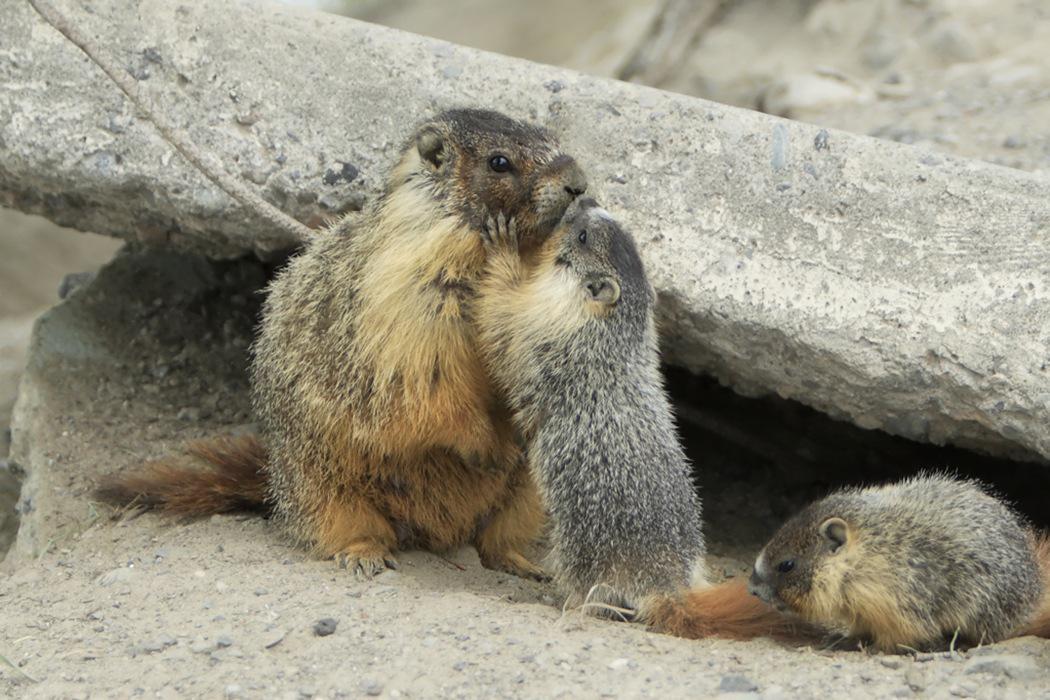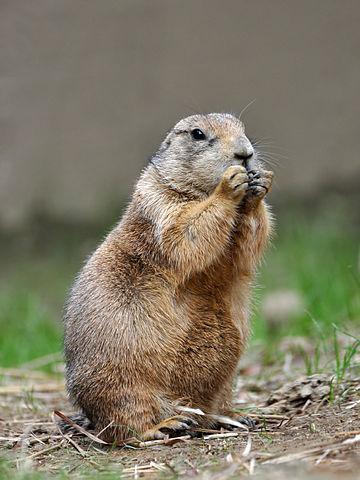The first image is the image on the left, the second image is the image on the right. Examine the images to the left and right. Is the description "At least one rodent-type animal is standing upright." accurate? Answer yes or no. Yes. 